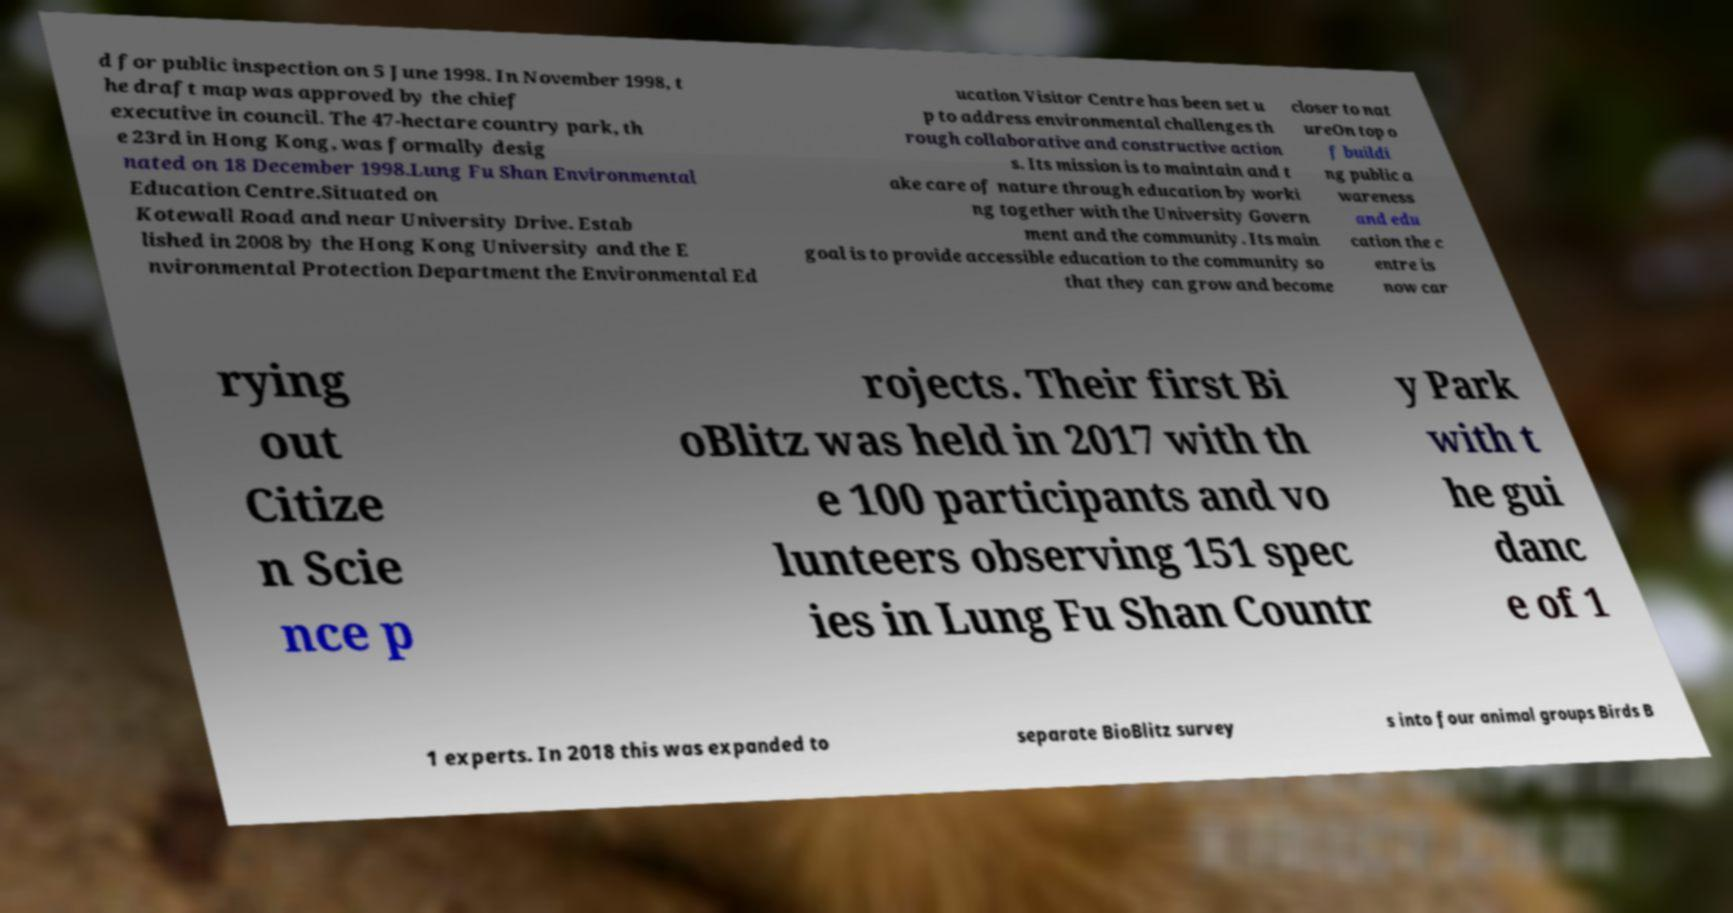For documentation purposes, I need the text within this image transcribed. Could you provide that? d for public inspection on 5 June 1998. In November 1998, t he draft map was approved by the chief executive in council. The 47-hectare country park, th e 23rd in Hong Kong, was formally desig nated on 18 December 1998.Lung Fu Shan Environmental Education Centre.Situated on Kotewall Road and near University Drive. Estab lished in 2008 by the Hong Kong University and the E nvironmental Protection Department the Environmental Ed ucation Visitor Centre has been set u p to address environmental challenges th rough collaborative and constructive action s. Its mission is to maintain and t ake care of nature through education by worki ng together with the University Govern ment and the community. Its main goal is to provide accessible education to the community so that they can grow and become closer to nat ureOn top o f buildi ng public a wareness and edu cation the c entre is now car rying out Citize n Scie nce p rojects. Their first Bi oBlitz was held in 2017 with th e 100 participants and vo lunteers observing 151 spec ies in Lung Fu Shan Countr y Park with t he gui danc e of 1 1 experts. In 2018 this was expanded to separate BioBlitz survey s into four animal groups Birds B 